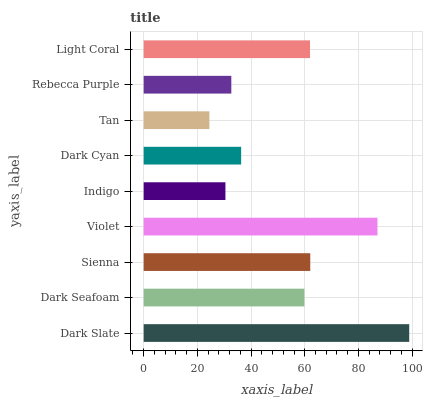Is Tan the minimum?
Answer yes or no. Yes. Is Dark Slate the maximum?
Answer yes or no. Yes. Is Dark Seafoam the minimum?
Answer yes or no. No. Is Dark Seafoam the maximum?
Answer yes or no. No. Is Dark Slate greater than Dark Seafoam?
Answer yes or no. Yes. Is Dark Seafoam less than Dark Slate?
Answer yes or no. Yes. Is Dark Seafoam greater than Dark Slate?
Answer yes or no. No. Is Dark Slate less than Dark Seafoam?
Answer yes or no. No. Is Dark Seafoam the high median?
Answer yes or no. Yes. Is Dark Seafoam the low median?
Answer yes or no. Yes. Is Violet the high median?
Answer yes or no. No. Is Sienna the low median?
Answer yes or no. No. 